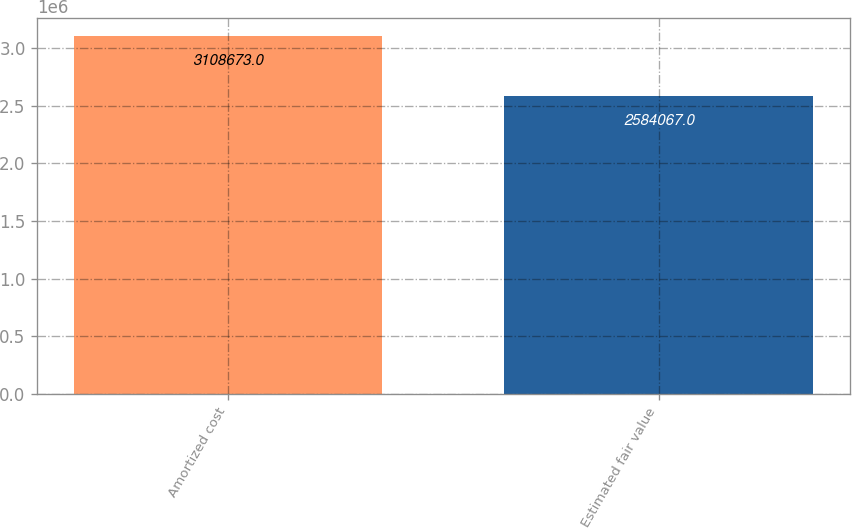<chart> <loc_0><loc_0><loc_500><loc_500><bar_chart><fcel>Amortized cost<fcel>Estimated fair value<nl><fcel>3.10867e+06<fcel>2.58407e+06<nl></chart> 